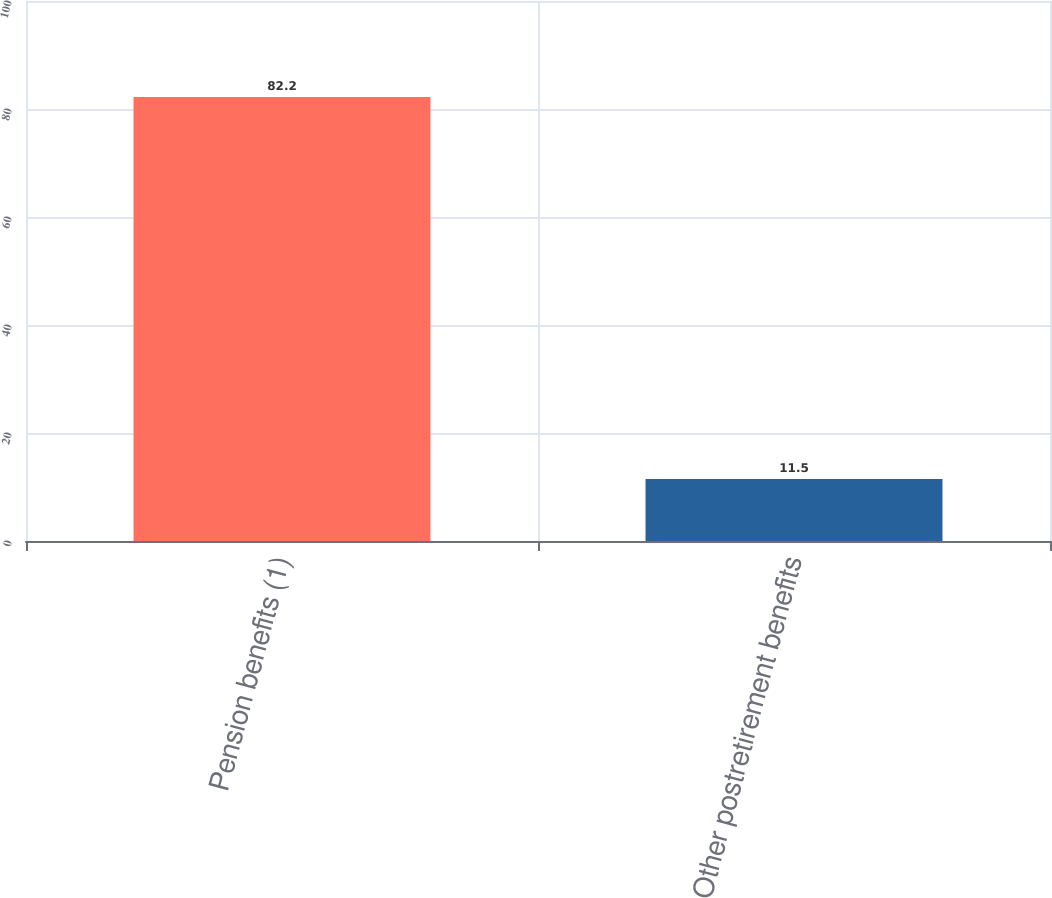Convert chart to OTSL. <chart><loc_0><loc_0><loc_500><loc_500><bar_chart><fcel>Pension benefits (1)<fcel>Other postretirement benefits<nl><fcel>82.2<fcel>11.5<nl></chart> 